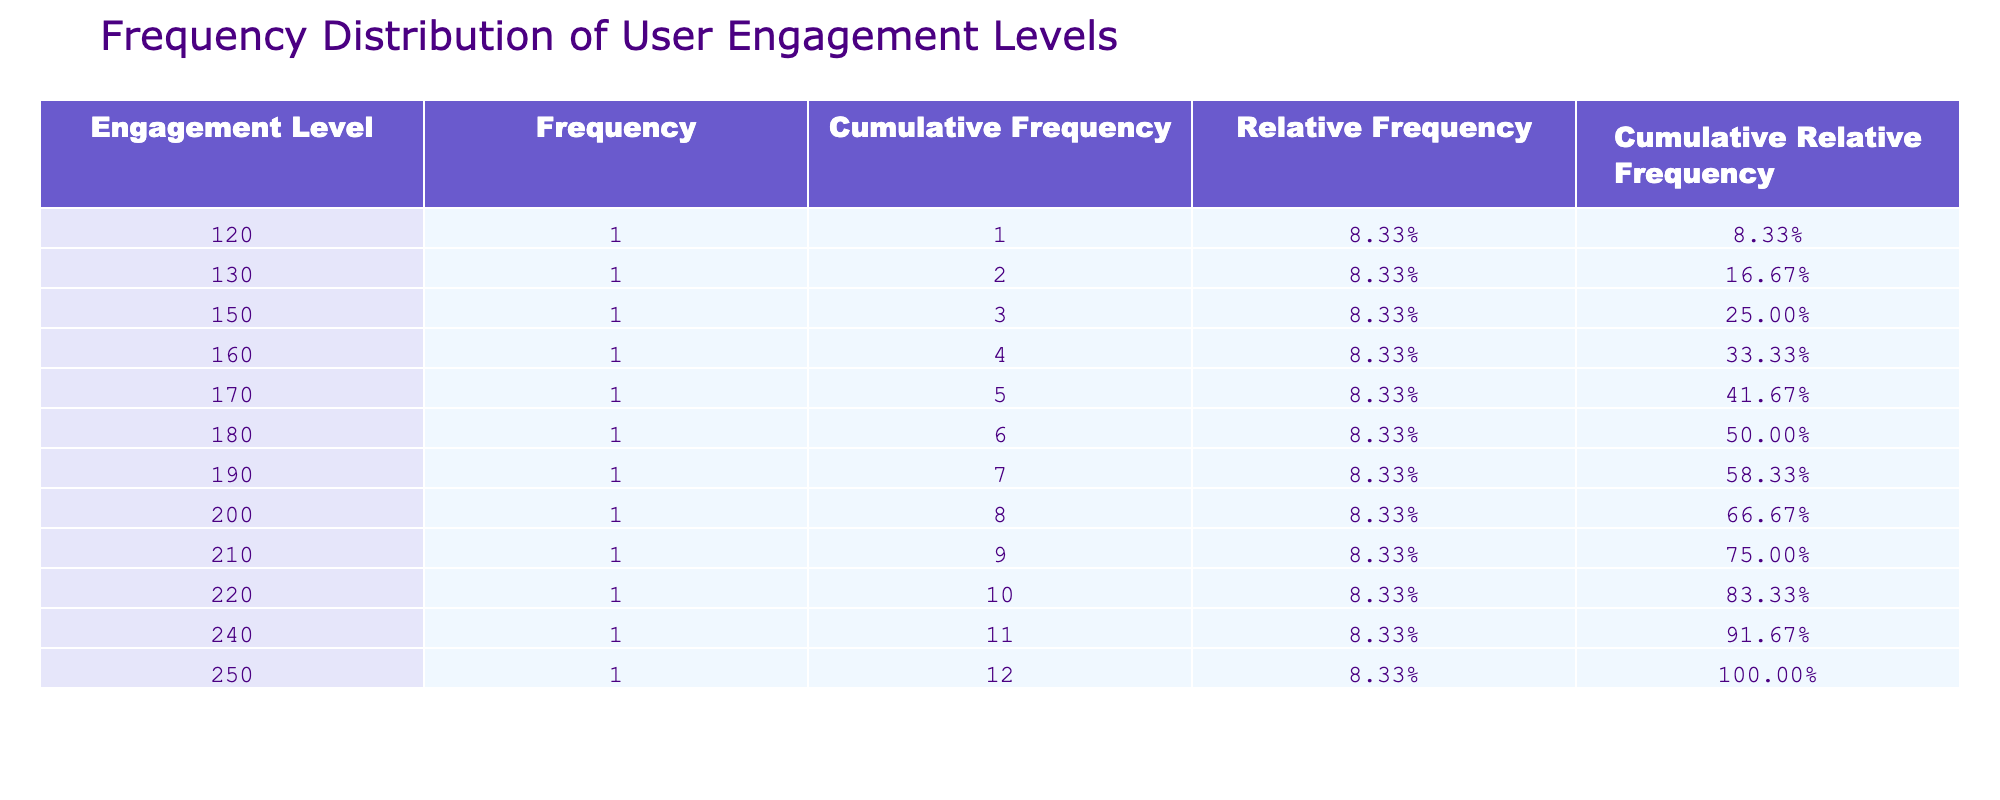What was the user engagement level in October 2023? The table shows that in October 2023, the user engagement level (posts) is listed as 240.
Answer: 240 Which month had the highest user engagement level? By examining the engagement levels for each month, December 2023 has the highest value at 250 posts.
Answer: 250 What is the cumulative frequency of user engagement levels for September 2023? To find this, we need to add up the frequencies of all months up to September. The cumulative frequency for September 2023 is 120 + 150 + 130 + 180 + 200 + 160 + 190 + 170 + 220 = 1,650.
Answer: 1650 Is there an increase in user engagement levels from April to May 2023? By comparing the two months, April 2023 has an engagement level of 180 and May 2023 has an engagement level of 200. Since 200 is greater than 180, this indicates an increase.
Answer: Yes What is the relative frequency of user engagement level of 220 posts? The relative frequency can be found by dividing the frequency of 220 posts by the total number of months (12). The frequency of 220 posts is 1, so the relative frequency is 1/12 = 0.0833 or 8.33%.
Answer: 8.33% What is the average user engagement level across all months? The average is calculated by summing all user engagement levels (120 + 150 + 130 + 180 + 200 + 160 + 190 + 170 + 220 + 240 + 210 + 250 = 2,250) and dividing by the number of months (12). The average is 2,250 / 12 = 187.5.
Answer: 187.5 What was the user engagement level in January 2023 compared to July 2023? In January 2023, the engagement level is 120 posts, while in July 2023 it is 190 posts. Comparing these values shows that July has a higher engagement level than January.
Answer: Yes Is the cumulative relative frequency for November 2023 greater than 60%? To find this, we look at the cumulative relative frequency for November 2023, which sums the relative frequencies from all months up to November. Adding these gives us a cumulative relative frequency greater than 60%.
Answer: Yes 